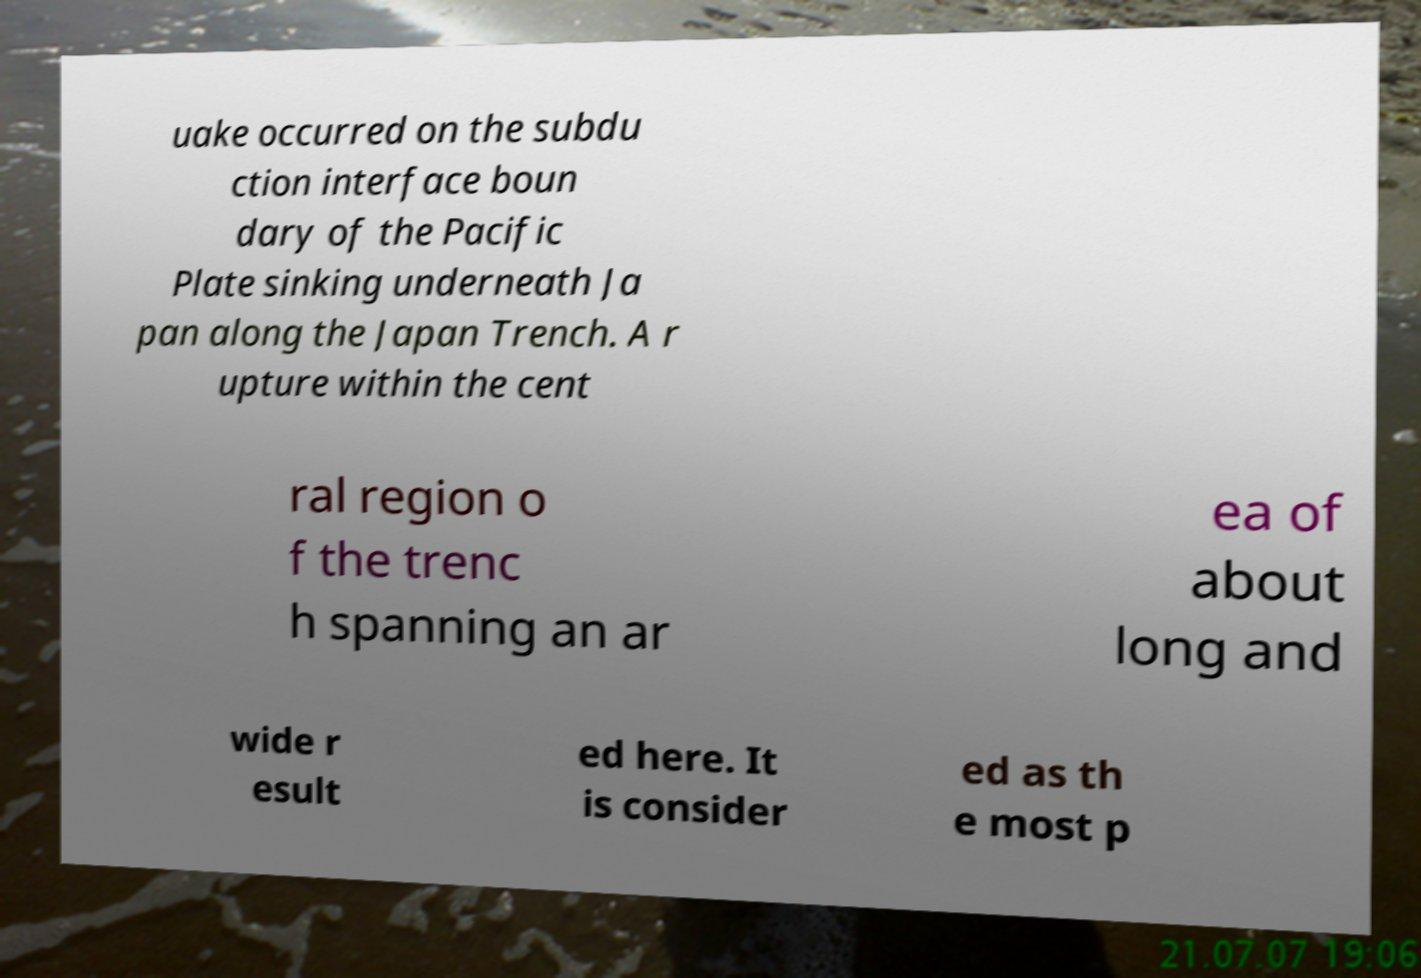Please identify and transcribe the text found in this image. uake occurred on the subdu ction interface boun dary of the Pacific Plate sinking underneath Ja pan along the Japan Trench. A r upture within the cent ral region o f the trenc h spanning an ar ea of about long and wide r esult ed here. It is consider ed as th e most p 